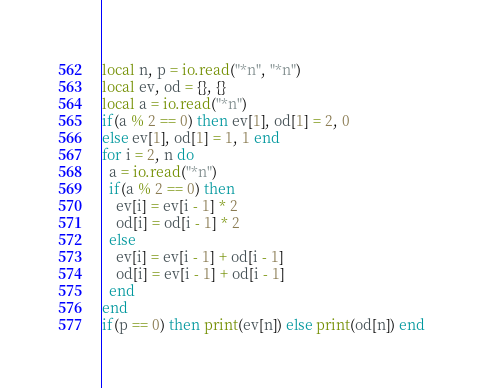Convert code to text. <code><loc_0><loc_0><loc_500><loc_500><_Lua_>local n, p = io.read("*n", "*n")
local ev, od = {}, {}
local a = io.read("*n")
if(a % 2 == 0) then ev[1], od[1] = 2, 0
else ev[1], od[1] = 1, 1 end
for i = 2, n do
  a = io.read("*n")
  if(a % 2 == 0) then
    ev[i] = ev[i - 1] * 2
    od[i] = od[i - 1] * 2
  else
    ev[i] = ev[i - 1] + od[i - 1]
    od[i] = ev[i - 1] + od[i - 1]
  end
end
if(p == 0) then print(ev[n]) else print(od[n]) end
</code> 